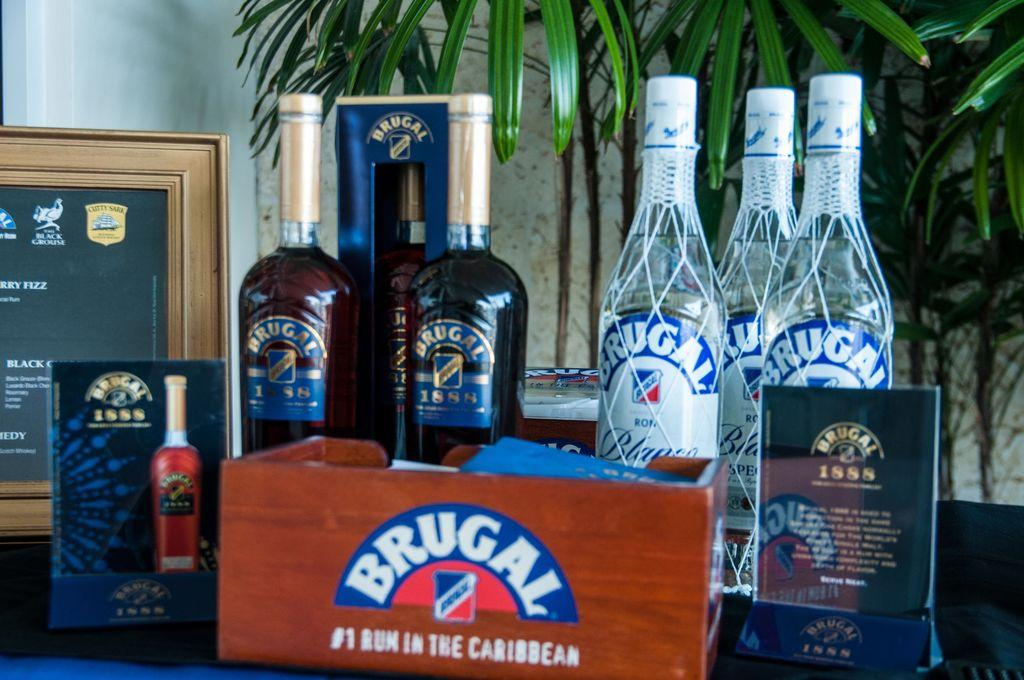Provide a one-sentence caption for the provided image. A wooden box with Brugal on it sits in front of bottles. 